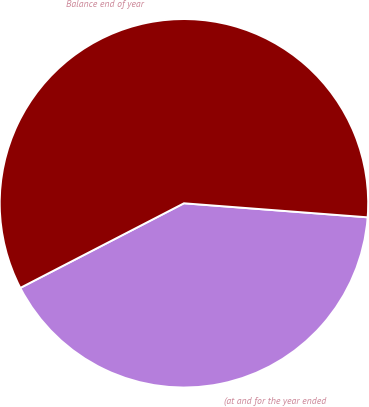Convert chart to OTSL. <chart><loc_0><loc_0><loc_500><loc_500><pie_chart><fcel>(at and for the year ended<fcel>Balance end of year<nl><fcel>41.19%<fcel>58.81%<nl></chart> 